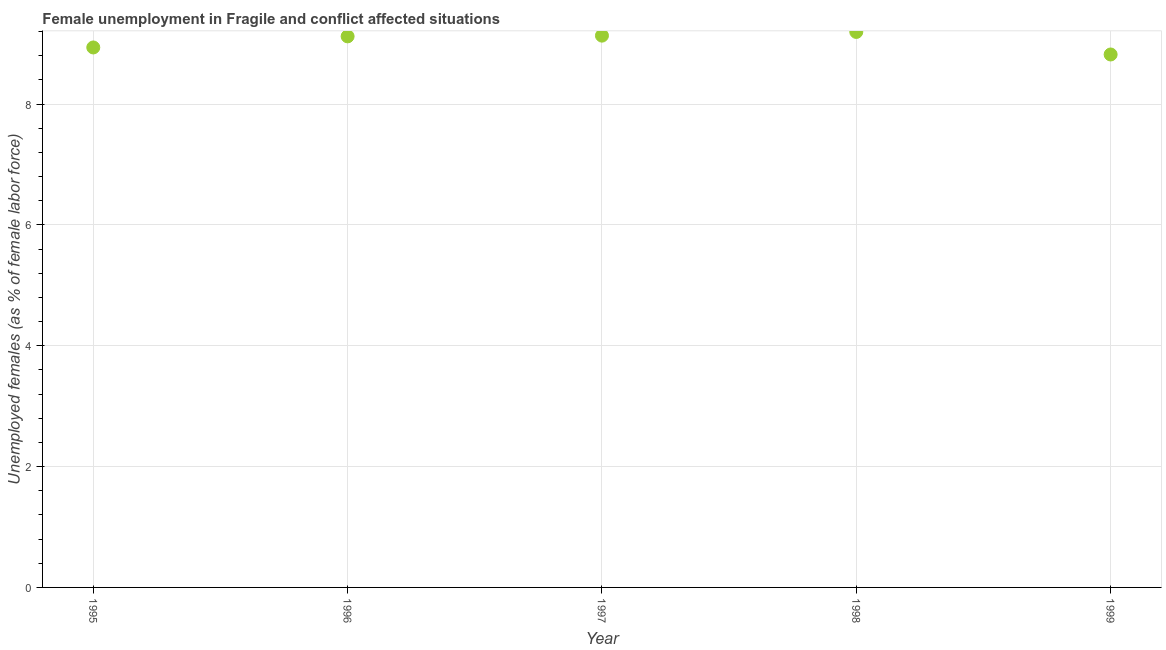What is the unemployed females population in 1999?
Provide a short and direct response. 8.82. Across all years, what is the maximum unemployed females population?
Ensure brevity in your answer.  9.2. Across all years, what is the minimum unemployed females population?
Offer a very short reply. 8.82. In which year was the unemployed females population maximum?
Ensure brevity in your answer.  1998. In which year was the unemployed females population minimum?
Provide a short and direct response. 1999. What is the sum of the unemployed females population?
Ensure brevity in your answer.  45.21. What is the difference between the unemployed females population in 1995 and 1996?
Ensure brevity in your answer.  -0.18. What is the average unemployed females population per year?
Your answer should be compact. 9.04. What is the median unemployed females population?
Offer a very short reply. 9.12. In how many years, is the unemployed females population greater than 0.4 %?
Ensure brevity in your answer.  5. Do a majority of the years between 1997 and 1996 (inclusive) have unemployed females population greater than 4.4 %?
Your answer should be very brief. No. What is the ratio of the unemployed females population in 1997 to that in 1999?
Provide a short and direct response. 1.04. What is the difference between the highest and the second highest unemployed females population?
Keep it short and to the point. 0.06. Is the sum of the unemployed females population in 1996 and 1998 greater than the maximum unemployed females population across all years?
Give a very brief answer. Yes. What is the difference between the highest and the lowest unemployed females population?
Give a very brief answer. 0.37. In how many years, is the unemployed females population greater than the average unemployed females population taken over all years?
Ensure brevity in your answer.  3. How many dotlines are there?
Offer a terse response. 1. How many years are there in the graph?
Offer a very short reply. 5. Does the graph contain any zero values?
Make the answer very short. No. Does the graph contain grids?
Give a very brief answer. Yes. What is the title of the graph?
Ensure brevity in your answer.  Female unemployment in Fragile and conflict affected situations. What is the label or title of the X-axis?
Your answer should be very brief. Year. What is the label or title of the Y-axis?
Offer a terse response. Unemployed females (as % of female labor force). What is the Unemployed females (as % of female labor force) in 1995?
Make the answer very short. 8.94. What is the Unemployed females (as % of female labor force) in 1996?
Make the answer very short. 9.12. What is the Unemployed females (as % of female labor force) in 1997?
Your answer should be compact. 9.13. What is the Unemployed females (as % of female labor force) in 1998?
Offer a terse response. 9.2. What is the Unemployed females (as % of female labor force) in 1999?
Your answer should be very brief. 8.82. What is the difference between the Unemployed females (as % of female labor force) in 1995 and 1996?
Your response must be concise. -0.18. What is the difference between the Unemployed females (as % of female labor force) in 1995 and 1997?
Give a very brief answer. -0.2. What is the difference between the Unemployed females (as % of female labor force) in 1995 and 1998?
Give a very brief answer. -0.26. What is the difference between the Unemployed females (as % of female labor force) in 1995 and 1999?
Give a very brief answer. 0.12. What is the difference between the Unemployed females (as % of female labor force) in 1996 and 1997?
Provide a short and direct response. -0.01. What is the difference between the Unemployed females (as % of female labor force) in 1996 and 1998?
Give a very brief answer. -0.07. What is the difference between the Unemployed females (as % of female labor force) in 1996 and 1999?
Give a very brief answer. 0.3. What is the difference between the Unemployed females (as % of female labor force) in 1997 and 1998?
Make the answer very short. -0.06. What is the difference between the Unemployed females (as % of female labor force) in 1997 and 1999?
Give a very brief answer. 0.31. What is the difference between the Unemployed females (as % of female labor force) in 1998 and 1999?
Make the answer very short. 0.37. What is the ratio of the Unemployed females (as % of female labor force) in 1995 to that in 1996?
Your response must be concise. 0.98. What is the ratio of the Unemployed females (as % of female labor force) in 1995 to that in 1997?
Your response must be concise. 0.98. What is the ratio of the Unemployed females (as % of female labor force) in 1995 to that in 1998?
Make the answer very short. 0.97. What is the ratio of the Unemployed females (as % of female labor force) in 1996 to that in 1998?
Make the answer very short. 0.99. What is the ratio of the Unemployed females (as % of female labor force) in 1996 to that in 1999?
Ensure brevity in your answer.  1.03. What is the ratio of the Unemployed females (as % of female labor force) in 1997 to that in 1999?
Offer a very short reply. 1.03. What is the ratio of the Unemployed females (as % of female labor force) in 1998 to that in 1999?
Your response must be concise. 1.04. 